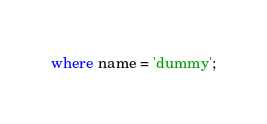Convert code to text. <code><loc_0><loc_0><loc_500><loc_500><_SQL_>where name = 'dummy';</code> 